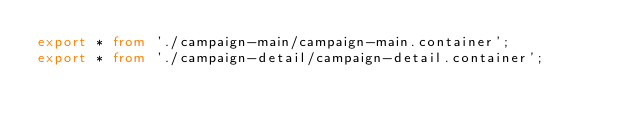<code> <loc_0><loc_0><loc_500><loc_500><_TypeScript_>export * from './campaign-main/campaign-main.container';
export * from './campaign-detail/campaign-detail.container';
</code> 